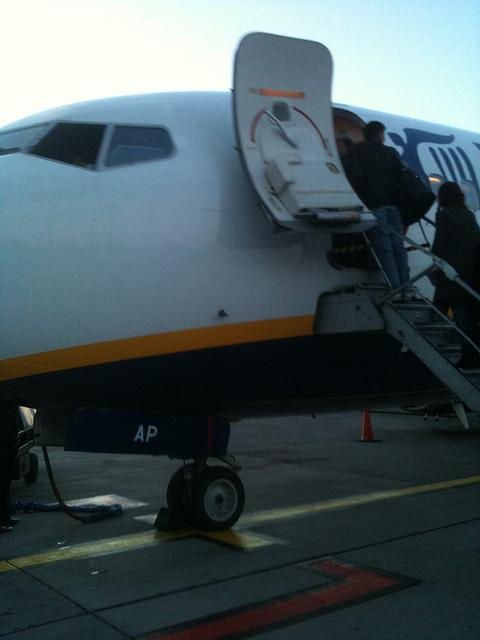What popular news agency as the same Acronym as the letters near the bottom of the plane? associated press 